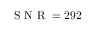<formula> <loc_0><loc_0><loc_500><loc_500>S N R = 2 9 2</formula> 